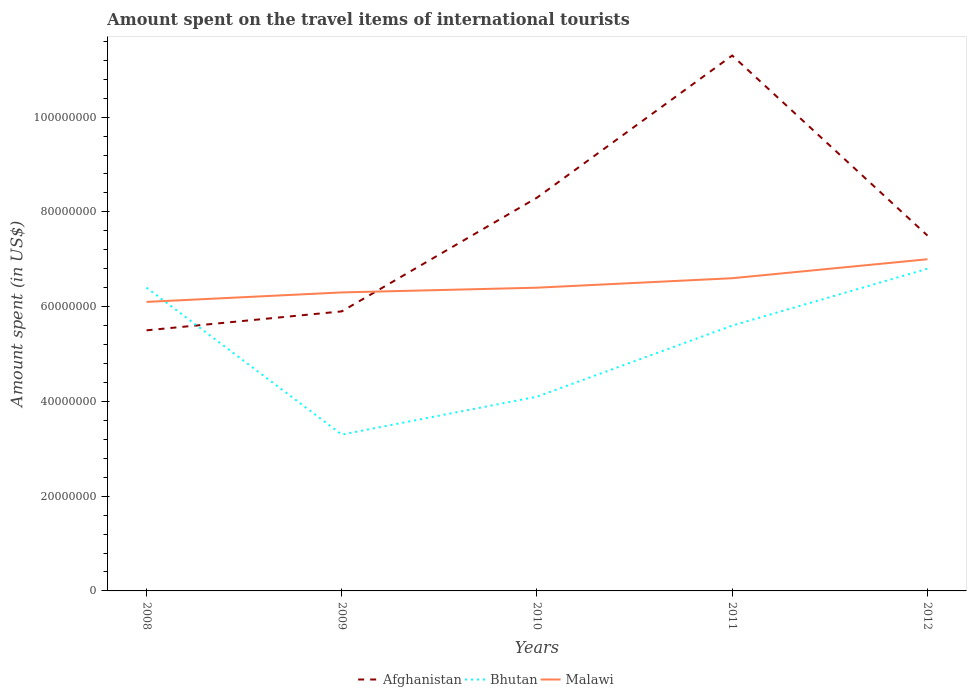Across all years, what is the maximum amount spent on the travel items of international tourists in Afghanistan?
Your response must be concise. 5.50e+07. In which year was the amount spent on the travel items of international tourists in Bhutan maximum?
Ensure brevity in your answer.  2009. What is the total amount spent on the travel items of international tourists in Afghanistan in the graph?
Your answer should be very brief. -3.00e+07. What is the difference between the highest and the second highest amount spent on the travel items of international tourists in Malawi?
Your answer should be compact. 9.00e+06. What is the difference between the highest and the lowest amount spent on the travel items of international tourists in Afghanistan?
Your response must be concise. 2. Is the amount spent on the travel items of international tourists in Malawi strictly greater than the amount spent on the travel items of international tourists in Afghanistan over the years?
Provide a succinct answer. No. How many lines are there?
Keep it short and to the point. 3. Are the values on the major ticks of Y-axis written in scientific E-notation?
Your response must be concise. No. Does the graph contain grids?
Ensure brevity in your answer.  No. Where does the legend appear in the graph?
Your answer should be compact. Bottom center. What is the title of the graph?
Your response must be concise. Amount spent on the travel items of international tourists. What is the label or title of the Y-axis?
Ensure brevity in your answer.  Amount spent (in US$). What is the Amount spent (in US$) of Afghanistan in 2008?
Your response must be concise. 5.50e+07. What is the Amount spent (in US$) of Bhutan in 2008?
Your answer should be very brief. 6.40e+07. What is the Amount spent (in US$) in Malawi in 2008?
Your answer should be very brief. 6.10e+07. What is the Amount spent (in US$) of Afghanistan in 2009?
Make the answer very short. 5.90e+07. What is the Amount spent (in US$) in Bhutan in 2009?
Provide a succinct answer. 3.30e+07. What is the Amount spent (in US$) of Malawi in 2009?
Make the answer very short. 6.30e+07. What is the Amount spent (in US$) of Afghanistan in 2010?
Provide a succinct answer. 8.30e+07. What is the Amount spent (in US$) in Bhutan in 2010?
Provide a succinct answer. 4.10e+07. What is the Amount spent (in US$) in Malawi in 2010?
Offer a terse response. 6.40e+07. What is the Amount spent (in US$) in Afghanistan in 2011?
Make the answer very short. 1.13e+08. What is the Amount spent (in US$) in Bhutan in 2011?
Make the answer very short. 5.60e+07. What is the Amount spent (in US$) of Malawi in 2011?
Provide a short and direct response. 6.60e+07. What is the Amount spent (in US$) of Afghanistan in 2012?
Offer a terse response. 7.50e+07. What is the Amount spent (in US$) in Bhutan in 2012?
Offer a terse response. 6.80e+07. What is the Amount spent (in US$) in Malawi in 2012?
Provide a succinct answer. 7.00e+07. Across all years, what is the maximum Amount spent (in US$) in Afghanistan?
Offer a terse response. 1.13e+08. Across all years, what is the maximum Amount spent (in US$) in Bhutan?
Your answer should be very brief. 6.80e+07. Across all years, what is the maximum Amount spent (in US$) in Malawi?
Give a very brief answer. 7.00e+07. Across all years, what is the minimum Amount spent (in US$) of Afghanistan?
Offer a terse response. 5.50e+07. Across all years, what is the minimum Amount spent (in US$) in Bhutan?
Ensure brevity in your answer.  3.30e+07. Across all years, what is the minimum Amount spent (in US$) in Malawi?
Ensure brevity in your answer.  6.10e+07. What is the total Amount spent (in US$) in Afghanistan in the graph?
Your answer should be compact. 3.85e+08. What is the total Amount spent (in US$) in Bhutan in the graph?
Keep it short and to the point. 2.62e+08. What is the total Amount spent (in US$) in Malawi in the graph?
Offer a terse response. 3.24e+08. What is the difference between the Amount spent (in US$) of Bhutan in 2008 and that in 2009?
Provide a succinct answer. 3.10e+07. What is the difference between the Amount spent (in US$) in Afghanistan in 2008 and that in 2010?
Your answer should be compact. -2.80e+07. What is the difference between the Amount spent (in US$) in Bhutan in 2008 and that in 2010?
Your response must be concise. 2.30e+07. What is the difference between the Amount spent (in US$) in Malawi in 2008 and that in 2010?
Ensure brevity in your answer.  -3.00e+06. What is the difference between the Amount spent (in US$) of Afghanistan in 2008 and that in 2011?
Provide a short and direct response. -5.80e+07. What is the difference between the Amount spent (in US$) in Malawi in 2008 and that in 2011?
Make the answer very short. -5.00e+06. What is the difference between the Amount spent (in US$) in Afghanistan in 2008 and that in 2012?
Offer a very short reply. -2.00e+07. What is the difference between the Amount spent (in US$) of Bhutan in 2008 and that in 2012?
Keep it short and to the point. -4.00e+06. What is the difference between the Amount spent (in US$) in Malawi in 2008 and that in 2012?
Offer a terse response. -9.00e+06. What is the difference between the Amount spent (in US$) in Afghanistan in 2009 and that in 2010?
Provide a short and direct response. -2.40e+07. What is the difference between the Amount spent (in US$) in Bhutan in 2009 and that in 2010?
Provide a short and direct response. -8.00e+06. What is the difference between the Amount spent (in US$) in Afghanistan in 2009 and that in 2011?
Your answer should be very brief. -5.40e+07. What is the difference between the Amount spent (in US$) in Bhutan in 2009 and that in 2011?
Offer a terse response. -2.30e+07. What is the difference between the Amount spent (in US$) in Afghanistan in 2009 and that in 2012?
Offer a very short reply. -1.60e+07. What is the difference between the Amount spent (in US$) of Bhutan in 2009 and that in 2012?
Your response must be concise. -3.50e+07. What is the difference between the Amount spent (in US$) of Malawi in 2009 and that in 2012?
Provide a succinct answer. -7.00e+06. What is the difference between the Amount spent (in US$) in Afghanistan in 2010 and that in 2011?
Provide a short and direct response. -3.00e+07. What is the difference between the Amount spent (in US$) of Bhutan in 2010 and that in 2011?
Your response must be concise. -1.50e+07. What is the difference between the Amount spent (in US$) of Malawi in 2010 and that in 2011?
Make the answer very short. -2.00e+06. What is the difference between the Amount spent (in US$) in Afghanistan in 2010 and that in 2012?
Your answer should be very brief. 8.00e+06. What is the difference between the Amount spent (in US$) in Bhutan in 2010 and that in 2012?
Your answer should be very brief. -2.70e+07. What is the difference between the Amount spent (in US$) in Malawi in 2010 and that in 2012?
Give a very brief answer. -6.00e+06. What is the difference between the Amount spent (in US$) of Afghanistan in 2011 and that in 2012?
Your answer should be very brief. 3.80e+07. What is the difference between the Amount spent (in US$) in Bhutan in 2011 and that in 2012?
Give a very brief answer. -1.20e+07. What is the difference between the Amount spent (in US$) in Afghanistan in 2008 and the Amount spent (in US$) in Bhutan in 2009?
Your answer should be compact. 2.20e+07. What is the difference between the Amount spent (in US$) in Afghanistan in 2008 and the Amount spent (in US$) in Malawi in 2009?
Your answer should be very brief. -8.00e+06. What is the difference between the Amount spent (in US$) in Bhutan in 2008 and the Amount spent (in US$) in Malawi in 2009?
Give a very brief answer. 1.00e+06. What is the difference between the Amount spent (in US$) in Afghanistan in 2008 and the Amount spent (in US$) in Bhutan in 2010?
Ensure brevity in your answer.  1.40e+07. What is the difference between the Amount spent (in US$) in Afghanistan in 2008 and the Amount spent (in US$) in Malawi in 2010?
Provide a succinct answer. -9.00e+06. What is the difference between the Amount spent (in US$) in Afghanistan in 2008 and the Amount spent (in US$) in Bhutan in 2011?
Your answer should be compact. -1.00e+06. What is the difference between the Amount spent (in US$) of Afghanistan in 2008 and the Amount spent (in US$) of Malawi in 2011?
Make the answer very short. -1.10e+07. What is the difference between the Amount spent (in US$) of Bhutan in 2008 and the Amount spent (in US$) of Malawi in 2011?
Provide a succinct answer. -2.00e+06. What is the difference between the Amount spent (in US$) in Afghanistan in 2008 and the Amount spent (in US$) in Bhutan in 2012?
Your answer should be compact. -1.30e+07. What is the difference between the Amount spent (in US$) of Afghanistan in 2008 and the Amount spent (in US$) of Malawi in 2012?
Your answer should be compact. -1.50e+07. What is the difference between the Amount spent (in US$) in Bhutan in 2008 and the Amount spent (in US$) in Malawi in 2012?
Offer a terse response. -6.00e+06. What is the difference between the Amount spent (in US$) of Afghanistan in 2009 and the Amount spent (in US$) of Bhutan in 2010?
Your response must be concise. 1.80e+07. What is the difference between the Amount spent (in US$) of Afghanistan in 2009 and the Amount spent (in US$) of Malawi in 2010?
Keep it short and to the point. -5.00e+06. What is the difference between the Amount spent (in US$) of Bhutan in 2009 and the Amount spent (in US$) of Malawi in 2010?
Keep it short and to the point. -3.10e+07. What is the difference between the Amount spent (in US$) of Afghanistan in 2009 and the Amount spent (in US$) of Bhutan in 2011?
Offer a very short reply. 3.00e+06. What is the difference between the Amount spent (in US$) in Afghanistan in 2009 and the Amount spent (in US$) in Malawi in 2011?
Provide a short and direct response. -7.00e+06. What is the difference between the Amount spent (in US$) in Bhutan in 2009 and the Amount spent (in US$) in Malawi in 2011?
Give a very brief answer. -3.30e+07. What is the difference between the Amount spent (in US$) of Afghanistan in 2009 and the Amount spent (in US$) of Bhutan in 2012?
Your answer should be very brief. -9.00e+06. What is the difference between the Amount spent (in US$) in Afghanistan in 2009 and the Amount spent (in US$) in Malawi in 2012?
Your response must be concise. -1.10e+07. What is the difference between the Amount spent (in US$) in Bhutan in 2009 and the Amount spent (in US$) in Malawi in 2012?
Make the answer very short. -3.70e+07. What is the difference between the Amount spent (in US$) of Afghanistan in 2010 and the Amount spent (in US$) of Bhutan in 2011?
Your answer should be compact. 2.70e+07. What is the difference between the Amount spent (in US$) of Afghanistan in 2010 and the Amount spent (in US$) of Malawi in 2011?
Your answer should be very brief. 1.70e+07. What is the difference between the Amount spent (in US$) in Bhutan in 2010 and the Amount spent (in US$) in Malawi in 2011?
Offer a terse response. -2.50e+07. What is the difference between the Amount spent (in US$) of Afghanistan in 2010 and the Amount spent (in US$) of Bhutan in 2012?
Make the answer very short. 1.50e+07. What is the difference between the Amount spent (in US$) in Afghanistan in 2010 and the Amount spent (in US$) in Malawi in 2012?
Your answer should be very brief. 1.30e+07. What is the difference between the Amount spent (in US$) of Bhutan in 2010 and the Amount spent (in US$) of Malawi in 2012?
Your response must be concise. -2.90e+07. What is the difference between the Amount spent (in US$) of Afghanistan in 2011 and the Amount spent (in US$) of Bhutan in 2012?
Your answer should be very brief. 4.50e+07. What is the difference between the Amount spent (in US$) in Afghanistan in 2011 and the Amount spent (in US$) in Malawi in 2012?
Ensure brevity in your answer.  4.30e+07. What is the difference between the Amount spent (in US$) of Bhutan in 2011 and the Amount spent (in US$) of Malawi in 2012?
Make the answer very short. -1.40e+07. What is the average Amount spent (in US$) in Afghanistan per year?
Your answer should be very brief. 7.70e+07. What is the average Amount spent (in US$) of Bhutan per year?
Keep it short and to the point. 5.24e+07. What is the average Amount spent (in US$) in Malawi per year?
Your response must be concise. 6.48e+07. In the year 2008, what is the difference between the Amount spent (in US$) of Afghanistan and Amount spent (in US$) of Bhutan?
Give a very brief answer. -9.00e+06. In the year 2008, what is the difference between the Amount spent (in US$) in Afghanistan and Amount spent (in US$) in Malawi?
Your answer should be very brief. -6.00e+06. In the year 2009, what is the difference between the Amount spent (in US$) in Afghanistan and Amount spent (in US$) in Bhutan?
Your answer should be compact. 2.60e+07. In the year 2009, what is the difference between the Amount spent (in US$) of Afghanistan and Amount spent (in US$) of Malawi?
Give a very brief answer. -4.00e+06. In the year 2009, what is the difference between the Amount spent (in US$) of Bhutan and Amount spent (in US$) of Malawi?
Offer a terse response. -3.00e+07. In the year 2010, what is the difference between the Amount spent (in US$) in Afghanistan and Amount spent (in US$) in Bhutan?
Provide a succinct answer. 4.20e+07. In the year 2010, what is the difference between the Amount spent (in US$) in Afghanistan and Amount spent (in US$) in Malawi?
Ensure brevity in your answer.  1.90e+07. In the year 2010, what is the difference between the Amount spent (in US$) in Bhutan and Amount spent (in US$) in Malawi?
Provide a short and direct response. -2.30e+07. In the year 2011, what is the difference between the Amount spent (in US$) of Afghanistan and Amount spent (in US$) of Bhutan?
Ensure brevity in your answer.  5.70e+07. In the year 2011, what is the difference between the Amount spent (in US$) of Afghanistan and Amount spent (in US$) of Malawi?
Provide a succinct answer. 4.70e+07. In the year 2011, what is the difference between the Amount spent (in US$) in Bhutan and Amount spent (in US$) in Malawi?
Provide a short and direct response. -1.00e+07. In the year 2012, what is the difference between the Amount spent (in US$) in Afghanistan and Amount spent (in US$) in Malawi?
Offer a terse response. 5.00e+06. What is the ratio of the Amount spent (in US$) in Afghanistan in 2008 to that in 2009?
Give a very brief answer. 0.93. What is the ratio of the Amount spent (in US$) in Bhutan in 2008 to that in 2009?
Your response must be concise. 1.94. What is the ratio of the Amount spent (in US$) in Malawi in 2008 to that in 2009?
Provide a short and direct response. 0.97. What is the ratio of the Amount spent (in US$) in Afghanistan in 2008 to that in 2010?
Make the answer very short. 0.66. What is the ratio of the Amount spent (in US$) of Bhutan in 2008 to that in 2010?
Give a very brief answer. 1.56. What is the ratio of the Amount spent (in US$) in Malawi in 2008 to that in 2010?
Provide a short and direct response. 0.95. What is the ratio of the Amount spent (in US$) in Afghanistan in 2008 to that in 2011?
Offer a terse response. 0.49. What is the ratio of the Amount spent (in US$) of Malawi in 2008 to that in 2011?
Make the answer very short. 0.92. What is the ratio of the Amount spent (in US$) in Afghanistan in 2008 to that in 2012?
Keep it short and to the point. 0.73. What is the ratio of the Amount spent (in US$) of Bhutan in 2008 to that in 2012?
Your answer should be compact. 0.94. What is the ratio of the Amount spent (in US$) in Malawi in 2008 to that in 2012?
Provide a succinct answer. 0.87. What is the ratio of the Amount spent (in US$) of Afghanistan in 2009 to that in 2010?
Your answer should be compact. 0.71. What is the ratio of the Amount spent (in US$) of Bhutan in 2009 to that in 2010?
Offer a very short reply. 0.8. What is the ratio of the Amount spent (in US$) in Malawi in 2009 to that in 2010?
Your answer should be very brief. 0.98. What is the ratio of the Amount spent (in US$) of Afghanistan in 2009 to that in 2011?
Make the answer very short. 0.52. What is the ratio of the Amount spent (in US$) of Bhutan in 2009 to that in 2011?
Offer a very short reply. 0.59. What is the ratio of the Amount spent (in US$) of Malawi in 2009 to that in 2011?
Keep it short and to the point. 0.95. What is the ratio of the Amount spent (in US$) in Afghanistan in 2009 to that in 2012?
Provide a succinct answer. 0.79. What is the ratio of the Amount spent (in US$) of Bhutan in 2009 to that in 2012?
Your response must be concise. 0.49. What is the ratio of the Amount spent (in US$) in Malawi in 2009 to that in 2012?
Offer a very short reply. 0.9. What is the ratio of the Amount spent (in US$) in Afghanistan in 2010 to that in 2011?
Your answer should be compact. 0.73. What is the ratio of the Amount spent (in US$) in Bhutan in 2010 to that in 2011?
Offer a terse response. 0.73. What is the ratio of the Amount spent (in US$) of Malawi in 2010 to that in 2011?
Keep it short and to the point. 0.97. What is the ratio of the Amount spent (in US$) in Afghanistan in 2010 to that in 2012?
Provide a succinct answer. 1.11. What is the ratio of the Amount spent (in US$) in Bhutan in 2010 to that in 2012?
Provide a succinct answer. 0.6. What is the ratio of the Amount spent (in US$) of Malawi in 2010 to that in 2012?
Your answer should be very brief. 0.91. What is the ratio of the Amount spent (in US$) in Afghanistan in 2011 to that in 2012?
Your response must be concise. 1.51. What is the ratio of the Amount spent (in US$) in Bhutan in 2011 to that in 2012?
Ensure brevity in your answer.  0.82. What is the ratio of the Amount spent (in US$) in Malawi in 2011 to that in 2012?
Your answer should be very brief. 0.94. What is the difference between the highest and the second highest Amount spent (in US$) in Afghanistan?
Your answer should be compact. 3.00e+07. What is the difference between the highest and the second highest Amount spent (in US$) in Malawi?
Offer a terse response. 4.00e+06. What is the difference between the highest and the lowest Amount spent (in US$) in Afghanistan?
Your answer should be very brief. 5.80e+07. What is the difference between the highest and the lowest Amount spent (in US$) of Bhutan?
Keep it short and to the point. 3.50e+07. What is the difference between the highest and the lowest Amount spent (in US$) of Malawi?
Give a very brief answer. 9.00e+06. 